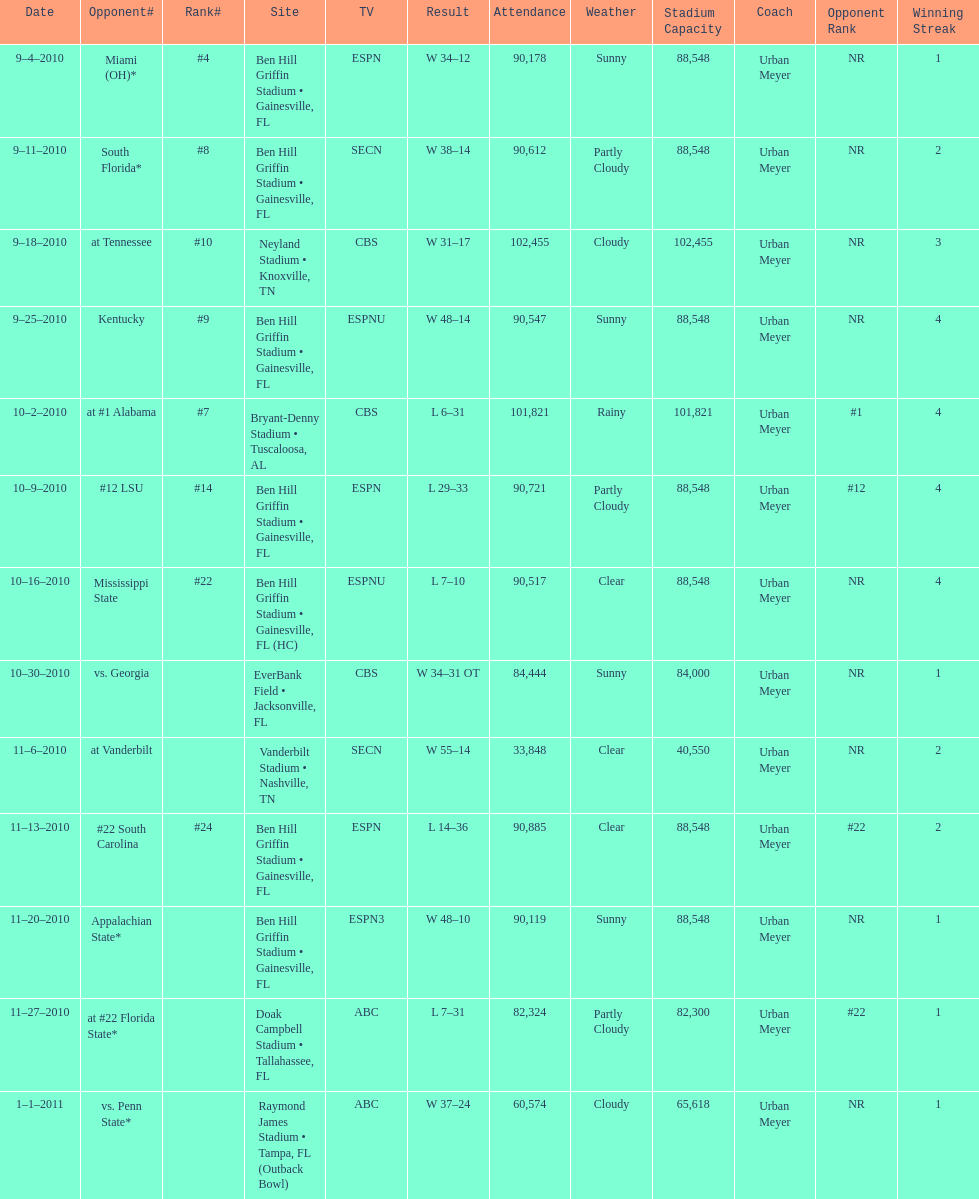How many consecutive weeks did the the gators win until the had their first lost in the 2010 season? 4. 